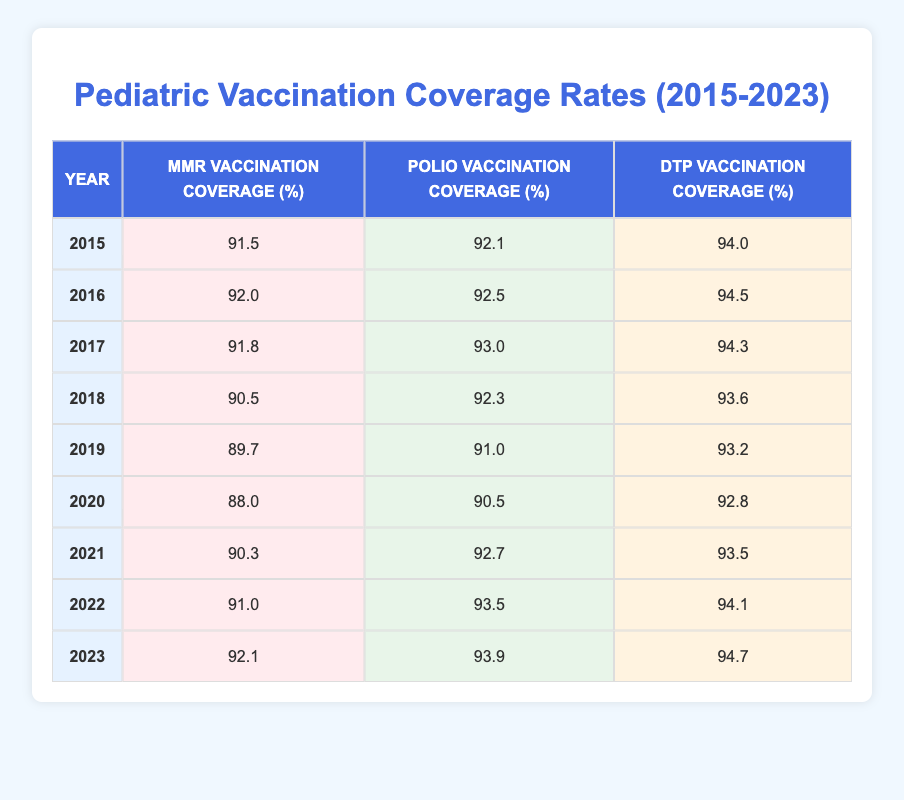What was the MMR vaccination coverage in 2017? The table indicates that the MMR vaccination coverage in 2017 is 91.8%
Answer: 91.8% In which year did the DTP vaccination coverage reach its lowest point? From the table, the lowest DTP vaccination coverage is 92.8%, which occurred in 2020
Answer: 2020 What is the difference between the highest and lowest Polio vaccination coverage rates from 2015 to 2023? The highest Polio vaccination coverage is 93.9% in 2023, and the lowest is 90.5% in 2020. The difference is 93.9 - 90.5 = 3.4
Answer: 3.4 Was the MMR vaccination coverage higher in 2022 than in 2015? In 2015, the MMR vaccination coverage was 91.5%, while in 2022 it was 91.0%. Therefore, it was not higher; it decreased.
Answer: No What is the average DTP vaccination coverage from 2015 to 2023? The DTP vaccination coverage rates for 2015-2023 are 94.0, 94.5, 94.3, 93.6, 93.2, 92.8, 93.5, 94.1, and 94.7. Adding these together gives 94.0 + 94.5 + 94.3 + 93.6 + 93.2 + 92.8 + 93.5 + 94.1 + 94.7 =  844.7. Dividing by the number of years (9) gives 844.7 / 9 = approximately 93.3.
Answer: 93.3 Did the MMR vaccination coverage consistently increase each year from 2015 to 2023? Examining the values, we see fluctuations; it increased in 2016, decreased in 2017 and 2018, continued to fall in 2019 and 2020, rose in 2021, 2022, and again in 2023. Thus, it did not consistently increase.
Answer: No 